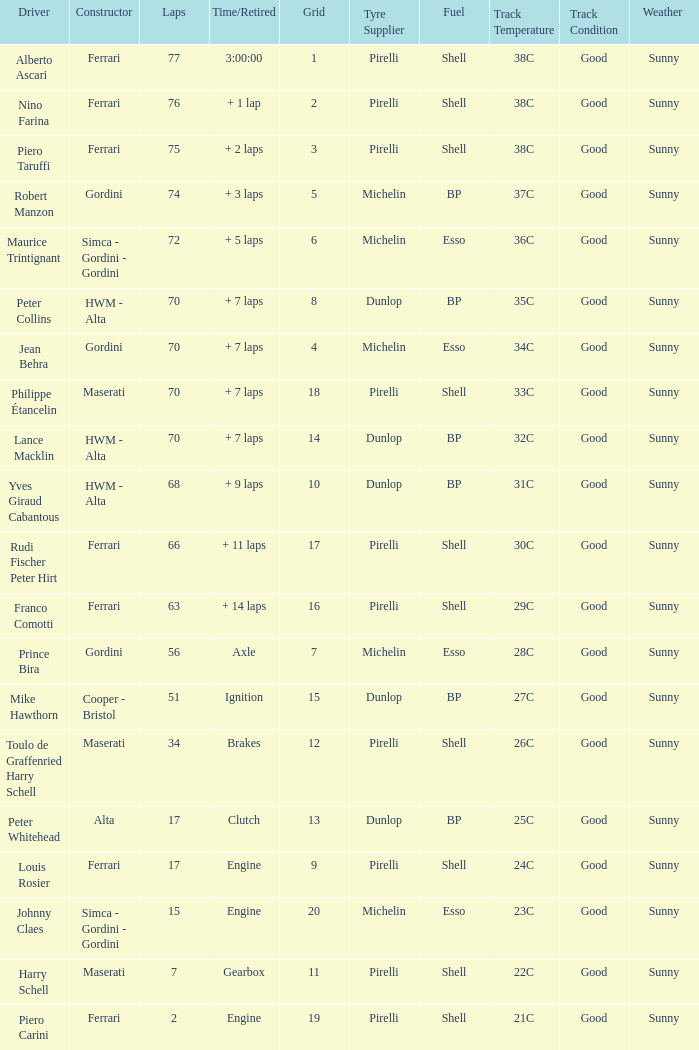What is the high grid for ferrari's with 2 laps? 19.0. 